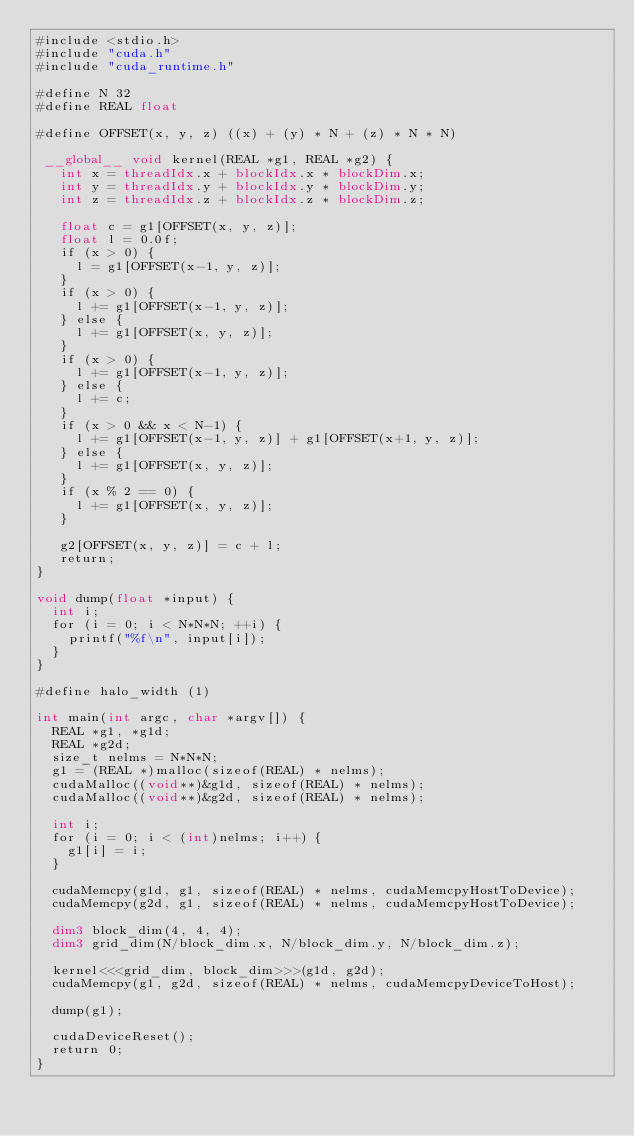<code> <loc_0><loc_0><loc_500><loc_500><_Cuda_>#include <stdio.h>
#include "cuda.h"
#include "cuda_runtime.h"

#define N 32
#define REAL float

#define OFFSET(x, y, z) ((x) + (y) * N + (z) * N * N)

 __global__ void kernel(REAL *g1, REAL *g2) {
   int x = threadIdx.x + blockIdx.x * blockDim.x;
   int y = threadIdx.y + blockIdx.y * blockDim.y;
   int z = threadIdx.z + blockIdx.z * blockDim.z;

   float c = g1[OFFSET(x, y, z)];
   float l = 0.0f;
   if (x > 0) {
     l = g1[OFFSET(x-1, y, z)];
   }
   if (x > 0) {
     l += g1[OFFSET(x-1, y, z)];
   } else {
     l += g1[OFFSET(x, y, z)];
   }
   if (x > 0) {
     l += g1[OFFSET(x-1, y, z)];
   } else {
     l += c;
   }
   if (x > 0 && x < N-1) {
     l += g1[OFFSET(x-1, y, z)] + g1[OFFSET(x+1, y, z)];
   } else {
     l += g1[OFFSET(x, y, z)];
   }
   if (x % 2 == 0) {
     l += g1[OFFSET(x, y, z)];
   }
   
   g2[OFFSET(x, y, z)] = c + l;
   return;
}

void dump(float *input) {
  int i;
  for (i = 0; i < N*N*N; ++i) {
    printf("%f\n", input[i]);
  }
}

#define halo_width (1)

int main(int argc, char *argv[]) {
  REAL *g1, *g1d;
  REAL *g2d;
  size_t nelms = N*N*N;
  g1 = (REAL *)malloc(sizeof(REAL) * nelms);
  cudaMalloc((void**)&g1d, sizeof(REAL) * nelms);
  cudaMalloc((void**)&g2d, sizeof(REAL) * nelms);

  int i;
  for (i = 0; i < (int)nelms; i++) {
    g1[i] = i;
  }
    
  cudaMemcpy(g1d, g1, sizeof(REAL) * nelms, cudaMemcpyHostToDevice);
  cudaMemcpy(g2d, g1, sizeof(REAL) * nelms, cudaMemcpyHostToDevice);  
  
  dim3 block_dim(4, 4, 4);
  dim3 grid_dim(N/block_dim.x, N/block_dim.y, N/block_dim.z);

  kernel<<<grid_dim, block_dim>>>(g1d, g2d);
  cudaMemcpy(g1, g2d, sizeof(REAL) * nelms, cudaMemcpyDeviceToHost);

  dump(g1);

  cudaDeviceReset();
  return 0;
}

</code> 